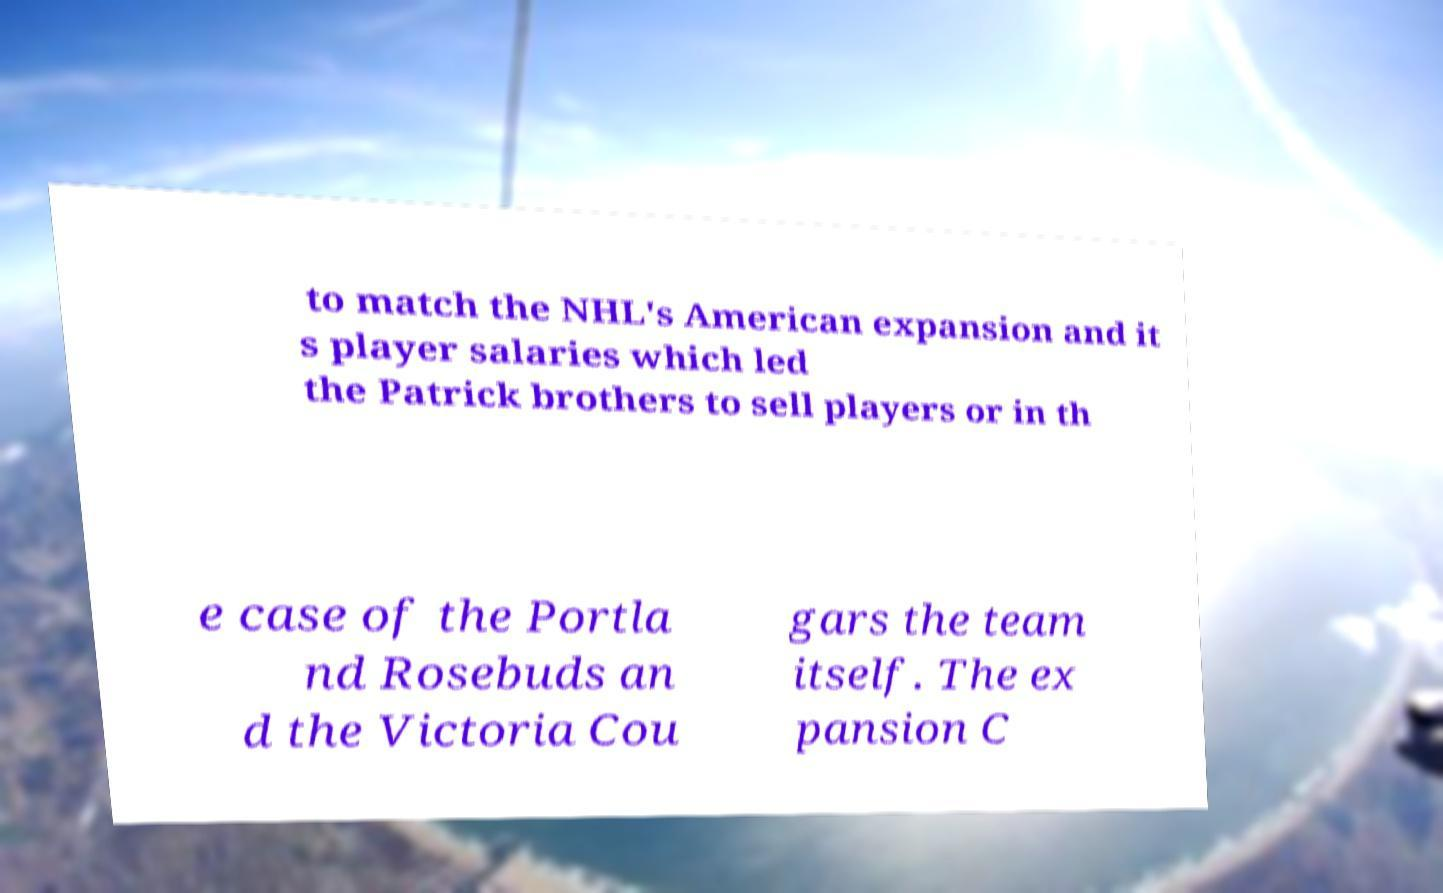Please identify and transcribe the text found in this image. to match the NHL's American expansion and it s player salaries which led the Patrick brothers to sell players or in th e case of the Portla nd Rosebuds an d the Victoria Cou gars the team itself. The ex pansion C 